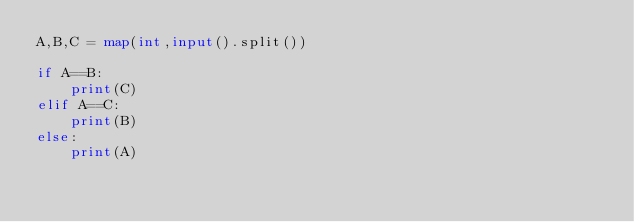<code> <loc_0><loc_0><loc_500><loc_500><_Python_>A,B,C = map(int,input().split())

if A==B:
    print(C)
elif A==C:
    print(B)
else:
    print(A)</code> 